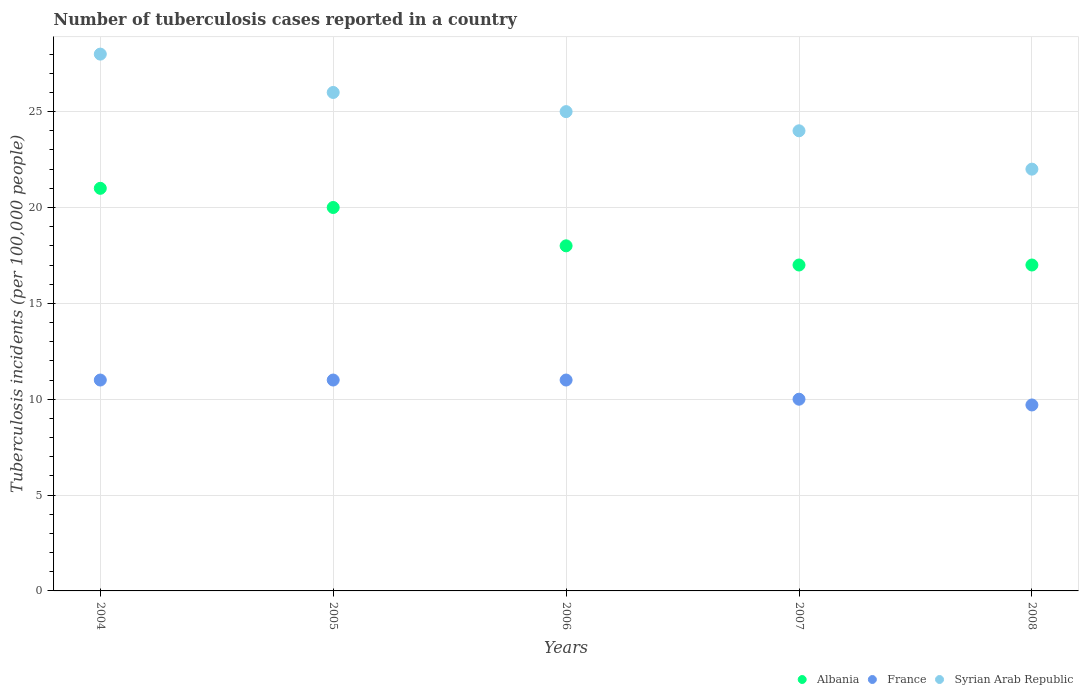Is the number of dotlines equal to the number of legend labels?
Offer a very short reply. Yes. What is the number of tuberculosis cases reported in in Syrian Arab Republic in 2005?
Your answer should be very brief. 26. Across all years, what is the minimum number of tuberculosis cases reported in in Syrian Arab Republic?
Keep it short and to the point. 22. In which year was the number of tuberculosis cases reported in in France minimum?
Your answer should be very brief. 2008. What is the total number of tuberculosis cases reported in in Syrian Arab Republic in the graph?
Your response must be concise. 125. What is the difference between the number of tuberculosis cases reported in in Albania in 2005 and that in 2008?
Provide a short and direct response. 3. What is the difference between the number of tuberculosis cases reported in in Syrian Arab Republic in 2005 and the number of tuberculosis cases reported in in Albania in 2008?
Provide a succinct answer. 9. What is the average number of tuberculosis cases reported in in Albania per year?
Provide a short and direct response. 18.6. What is the ratio of the number of tuberculosis cases reported in in Albania in 2006 to that in 2007?
Provide a succinct answer. 1.06. Is the difference between the number of tuberculosis cases reported in in France in 2005 and 2006 greater than the difference between the number of tuberculosis cases reported in in Syrian Arab Republic in 2005 and 2006?
Keep it short and to the point. No. What is the difference between the highest and the lowest number of tuberculosis cases reported in in Albania?
Your answer should be compact. 4. Is the sum of the number of tuberculosis cases reported in in France in 2005 and 2008 greater than the maximum number of tuberculosis cases reported in in Albania across all years?
Offer a terse response. No. Is it the case that in every year, the sum of the number of tuberculosis cases reported in in Syrian Arab Republic and number of tuberculosis cases reported in in France  is greater than the number of tuberculosis cases reported in in Albania?
Provide a succinct answer. Yes. Is the number of tuberculosis cases reported in in Syrian Arab Republic strictly greater than the number of tuberculosis cases reported in in France over the years?
Your answer should be compact. Yes. How many years are there in the graph?
Keep it short and to the point. 5. Are the values on the major ticks of Y-axis written in scientific E-notation?
Provide a succinct answer. No. Does the graph contain any zero values?
Your answer should be very brief. No. How many legend labels are there?
Your answer should be compact. 3. How are the legend labels stacked?
Your answer should be compact. Horizontal. What is the title of the graph?
Offer a very short reply. Number of tuberculosis cases reported in a country. Does "Nepal" appear as one of the legend labels in the graph?
Provide a succinct answer. No. What is the label or title of the X-axis?
Ensure brevity in your answer.  Years. What is the label or title of the Y-axis?
Keep it short and to the point. Tuberculosis incidents (per 100,0 people). What is the Tuberculosis incidents (per 100,000 people) of Syrian Arab Republic in 2004?
Offer a very short reply. 28. What is the Tuberculosis incidents (per 100,000 people) in Syrian Arab Republic in 2005?
Your response must be concise. 26. What is the Tuberculosis incidents (per 100,000 people) of France in 2006?
Ensure brevity in your answer.  11. What is the Tuberculosis incidents (per 100,000 people) of Albania in 2007?
Provide a succinct answer. 17. What is the Tuberculosis incidents (per 100,000 people) of France in 2007?
Your answer should be very brief. 10. What is the Tuberculosis incidents (per 100,000 people) in Syrian Arab Republic in 2007?
Provide a succinct answer. 24. Across all years, what is the maximum Tuberculosis incidents (per 100,000 people) in Albania?
Ensure brevity in your answer.  21. Across all years, what is the minimum Tuberculosis incidents (per 100,000 people) in France?
Provide a short and direct response. 9.7. Across all years, what is the minimum Tuberculosis incidents (per 100,000 people) in Syrian Arab Republic?
Keep it short and to the point. 22. What is the total Tuberculosis incidents (per 100,000 people) in Albania in the graph?
Make the answer very short. 93. What is the total Tuberculosis incidents (per 100,000 people) in France in the graph?
Provide a succinct answer. 52.7. What is the total Tuberculosis incidents (per 100,000 people) in Syrian Arab Republic in the graph?
Provide a succinct answer. 125. What is the difference between the Tuberculosis incidents (per 100,000 people) in Albania in 2004 and that in 2005?
Provide a succinct answer. 1. What is the difference between the Tuberculosis incidents (per 100,000 people) in France in 2004 and that in 2005?
Make the answer very short. 0. What is the difference between the Tuberculosis incidents (per 100,000 people) of Syrian Arab Republic in 2004 and that in 2005?
Keep it short and to the point. 2. What is the difference between the Tuberculosis incidents (per 100,000 people) of Syrian Arab Republic in 2004 and that in 2006?
Make the answer very short. 3. What is the difference between the Tuberculosis incidents (per 100,000 people) in France in 2004 and that in 2007?
Ensure brevity in your answer.  1. What is the difference between the Tuberculosis incidents (per 100,000 people) in Albania in 2004 and that in 2008?
Give a very brief answer. 4. What is the difference between the Tuberculosis incidents (per 100,000 people) in France in 2004 and that in 2008?
Provide a succinct answer. 1.3. What is the difference between the Tuberculosis incidents (per 100,000 people) of Syrian Arab Republic in 2004 and that in 2008?
Your response must be concise. 6. What is the difference between the Tuberculosis incidents (per 100,000 people) in Syrian Arab Republic in 2005 and that in 2006?
Offer a very short reply. 1. What is the difference between the Tuberculosis incidents (per 100,000 people) in Albania in 2005 and that in 2007?
Your answer should be compact. 3. What is the difference between the Tuberculosis incidents (per 100,000 people) of Syrian Arab Republic in 2005 and that in 2007?
Provide a succinct answer. 2. What is the difference between the Tuberculosis incidents (per 100,000 people) of Syrian Arab Republic in 2005 and that in 2008?
Keep it short and to the point. 4. What is the difference between the Tuberculosis incidents (per 100,000 people) in Syrian Arab Republic in 2006 and that in 2008?
Your answer should be very brief. 3. What is the difference between the Tuberculosis incidents (per 100,000 people) of Albania in 2007 and that in 2008?
Provide a succinct answer. 0. What is the difference between the Tuberculosis incidents (per 100,000 people) of France in 2007 and that in 2008?
Give a very brief answer. 0.3. What is the difference between the Tuberculosis incidents (per 100,000 people) of France in 2004 and the Tuberculosis incidents (per 100,000 people) of Syrian Arab Republic in 2005?
Give a very brief answer. -15. What is the difference between the Tuberculosis incidents (per 100,000 people) of Albania in 2004 and the Tuberculosis incidents (per 100,000 people) of Syrian Arab Republic in 2006?
Make the answer very short. -4. What is the difference between the Tuberculosis incidents (per 100,000 people) of Albania in 2004 and the Tuberculosis incidents (per 100,000 people) of France in 2007?
Offer a terse response. 11. What is the difference between the Tuberculosis incidents (per 100,000 people) of Albania in 2004 and the Tuberculosis incidents (per 100,000 people) of Syrian Arab Republic in 2007?
Provide a succinct answer. -3. What is the difference between the Tuberculosis incidents (per 100,000 people) in France in 2004 and the Tuberculosis incidents (per 100,000 people) in Syrian Arab Republic in 2007?
Your response must be concise. -13. What is the difference between the Tuberculosis incidents (per 100,000 people) of Albania in 2004 and the Tuberculosis incidents (per 100,000 people) of France in 2008?
Provide a short and direct response. 11.3. What is the difference between the Tuberculosis incidents (per 100,000 people) of Albania in 2004 and the Tuberculosis incidents (per 100,000 people) of Syrian Arab Republic in 2008?
Make the answer very short. -1. What is the difference between the Tuberculosis incidents (per 100,000 people) in Albania in 2005 and the Tuberculosis incidents (per 100,000 people) in France in 2006?
Your response must be concise. 9. What is the difference between the Tuberculosis incidents (per 100,000 people) in Albania in 2005 and the Tuberculosis incidents (per 100,000 people) in France in 2007?
Offer a terse response. 10. What is the difference between the Tuberculosis incidents (per 100,000 people) in Albania in 2005 and the Tuberculosis incidents (per 100,000 people) in Syrian Arab Republic in 2007?
Make the answer very short. -4. What is the difference between the Tuberculosis incidents (per 100,000 people) in Albania in 2005 and the Tuberculosis incidents (per 100,000 people) in France in 2008?
Offer a very short reply. 10.3. What is the difference between the Tuberculosis incidents (per 100,000 people) in France in 2005 and the Tuberculosis incidents (per 100,000 people) in Syrian Arab Republic in 2008?
Provide a short and direct response. -11. What is the difference between the Tuberculosis incidents (per 100,000 people) in Albania in 2007 and the Tuberculosis incidents (per 100,000 people) in France in 2008?
Make the answer very short. 7.3. What is the average Tuberculosis incidents (per 100,000 people) of Albania per year?
Make the answer very short. 18.6. What is the average Tuberculosis incidents (per 100,000 people) of France per year?
Make the answer very short. 10.54. In the year 2005, what is the difference between the Tuberculosis incidents (per 100,000 people) in Albania and Tuberculosis incidents (per 100,000 people) in France?
Your answer should be compact. 9. In the year 2005, what is the difference between the Tuberculosis incidents (per 100,000 people) in France and Tuberculosis incidents (per 100,000 people) in Syrian Arab Republic?
Offer a very short reply. -15. In the year 2006, what is the difference between the Tuberculosis incidents (per 100,000 people) in Albania and Tuberculosis incidents (per 100,000 people) in France?
Your answer should be very brief. 7. In the year 2008, what is the difference between the Tuberculosis incidents (per 100,000 people) in Albania and Tuberculosis incidents (per 100,000 people) in France?
Provide a succinct answer. 7.3. In the year 2008, what is the difference between the Tuberculosis incidents (per 100,000 people) in Albania and Tuberculosis incidents (per 100,000 people) in Syrian Arab Republic?
Provide a short and direct response. -5. In the year 2008, what is the difference between the Tuberculosis incidents (per 100,000 people) of France and Tuberculosis incidents (per 100,000 people) of Syrian Arab Republic?
Offer a very short reply. -12.3. What is the ratio of the Tuberculosis incidents (per 100,000 people) in Syrian Arab Republic in 2004 to that in 2005?
Make the answer very short. 1.08. What is the ratio of the Tuberculosis incidents (per 100,000 people) in Syrian Arab Republic in 2004 to that in 2006?
Your response must be concise. 1.12. What is the ratio of the Tuberculosis incidents (per 100,000 people) of Albania in 2004 to that in 2007?
Provide a short and direct response. 1.24. What is the ratio of the Tuberculosis incidents (per 100,000 people) in France in 2004 to that in 2007?
Keep it short and to the point. 1.1. What is the ratio of the Tuberculosis incidents (per 100,000 people) in Albania in 2004 to that in 2008?
Your answer should be very brief. 1.24. What is the ratio of the Tuberculosis incidents (per 100,000 people) in France in 2004 to that in 2008?
Ensure brevity in your answer.  1.13. What is the ratio of the Tuberculosis incidents (per 100,000 people) of Syrian Arab Republic in 2004 to that in 2008?
Your answer should be very brief. 1.27. What is the ratio of the Tuberculosis incidents (per 100,000 people) in Albania in 2005 to that in 2006?
Your answer should be very brief. 1.11. What is the ratio of the Tuberculosis incidents (per 100,000 people) of France in 2005 to that in 2006?
Your response must be concise. 1. What is the ratio of the Tuberculosis incidents (per 100,000 people) in Syrian Arab Republic in 2005 to that in 2006?
Offer a very short reply. 1.04. What is the ratio of the Tuberculosis incidents (per 100,000 people) in Albania in 2005 to that in 2007?
Ensure brevity in your answer.  1.18. What is the ratio of the Tuberculosis incidents (per 100,000 people) in France in 2005 to that in 2007?
Offer a very short reply. 1.1. What is the ratio of the Tuberculosis incidents (per 100,000 people) of Albania in 2005 to that in 2008?
Provide a short and direct response. 1.18. What is the ratio of the Tuberculosis incidents (per 100,000 people) of France in 2005 to that in 2008?
Offer a terse response. 1.13. What is the ratio of the Tuberculosis incidents (per 100,000 people) in Syrian Arab Republic in 2005 to that in 2008?
Your answer should be very brief. 1.18. What is the ratio of the Tuberculosis incidents (per 100,000 people) in Albania in 2006 to that in 2007?
Your answer should be very brief. 1.06. What is the ratio of the Tuberculosis incidents (per 100,000 people) in France in 2006 to that in 2007?
Your answer should be very brief. 1.1. What is the ratio of the Tuberculosis incidents (per 100,000 people) of Syrian Arab Republic in 2006 to that in 2007?
Your answer should be compact. 1.04. What is the ratio of the Tuberculosis incidents (per 100,000 people) of Albania in 2006 to that in 2008?
Offer a terse response. 1.06. What is the ratio of the Tuberculosis incidents (per 100,000 people) of France in 2006 to that in 2008?
Offer a terse response. 1.13. What is the ratio of the Tuberculosis incidents (per 100,000 people) of Syrian Arab Republic in 2006 to that in 2008?
Your response must be concise. 1.14. What is the ratio of the Tuberculosis incidents (per 100,000 people) of France in 2007 to that in 2008?
Ensure brevity in your answer.  1.03. What is the difference between the highest and the second highest Tuberculosis incidents (per 100,000 people) of Albania?
Your answer should be compact. 1. What is the difference between the highest and the second highest Tuberculosis incidents (per 100,000 people) of Syrian Arab Republic?
Your answer should be compact. 2. What is the difference between the highest and the lowest Tuberculosis incidents (per 100,000 people) of France?
Keep it short and to the point. 1.3. What is the difference between the highest and the lowest Tuberculosis incidents (per 100,000 people) of Syrian Arab Republic?
Your answer should be very brief. 6. 